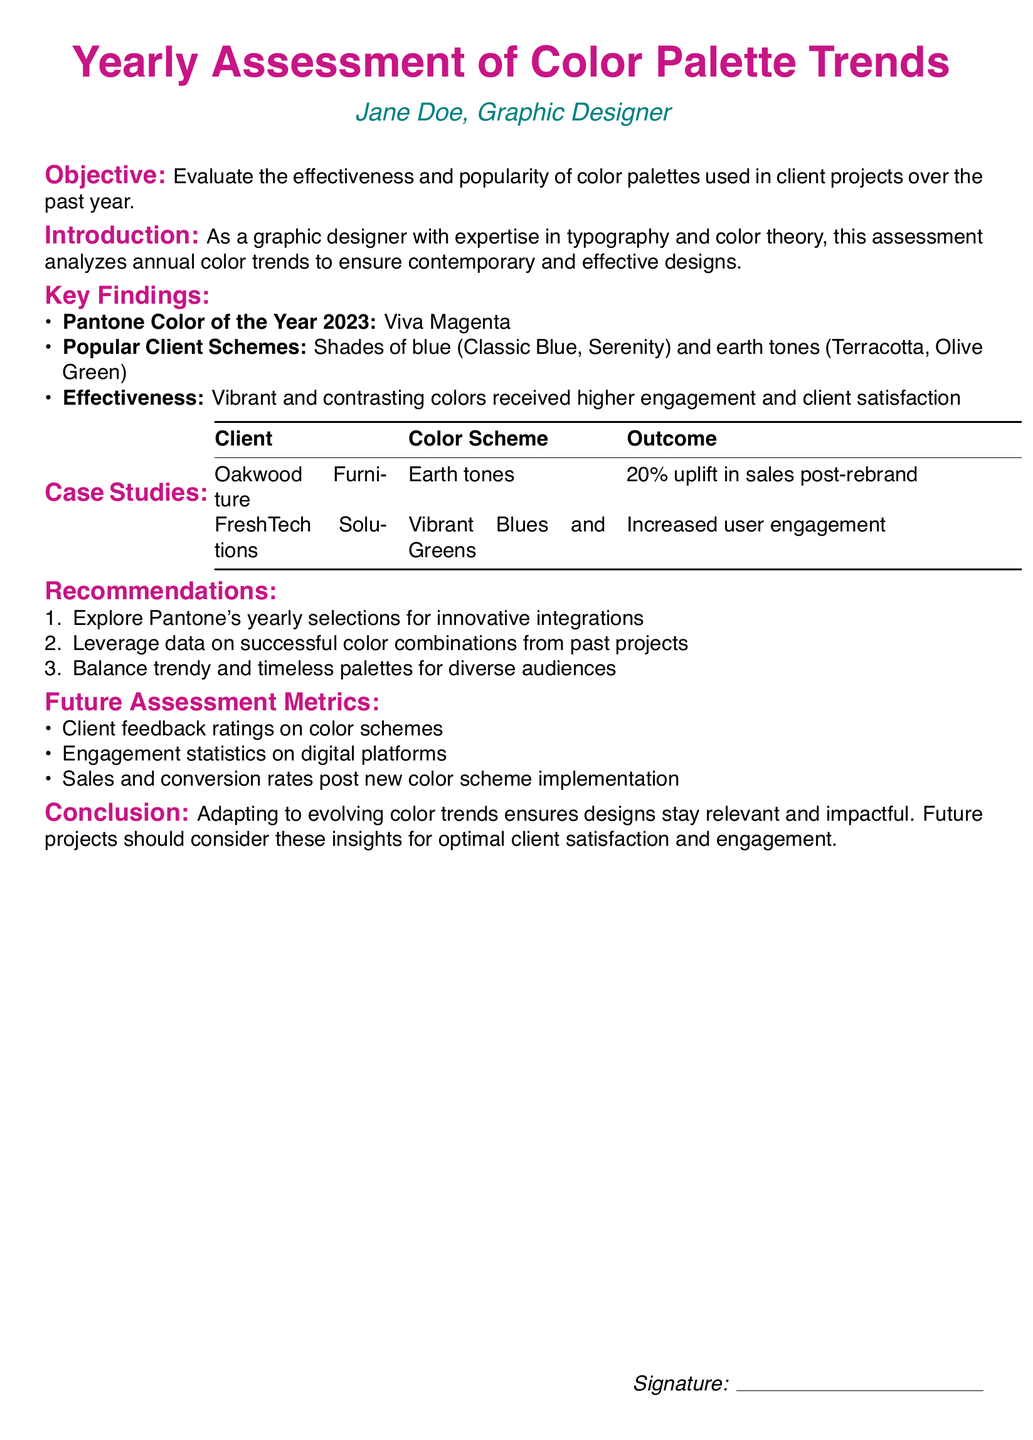What is the Pantone Color of the Year 2023? The document mentions that the Pantone Color of the Year 2023 is "Viva Magenta."
Answer: Viva Magenta Which client experienced a 20% uplift in sales? The document states that "Oakwood Furniture" had a 20% uplift in sales post-rebrand.
Answer: Oakwood Furniture What color schemes were noted as popular among clients? The assessment lists "Shades of blue" and "earth tones" as popular color schemes.
Answer: Shades of blue and earth tones What type of outcomes were achieved with vibrant colors? The document indicates that vibrant colors received "higher engagement and client satisfaction."
Answer: Higher engagement and client satisfaction What is one of the recommendations for future projects? The document suggests exploring "Pantone's yearly selections for innovative integrations" as a recommendation.
Answer: Explore Pantone's yearly selections Which organization is represented by Jane Doe? The document lists "Jane Doe" as the graphic designer.
Answer: Jane Doe What is included in the future assessment metrics? The document lists "Client feedback ratings on color schemes" as one of the metrics.
Answer: Client feedback ratings on color schemes How much sales uplift did Oakwood Furniture achieve? The document states a "20% uplift in sales" for Oakwood Furniture.
Answer: 20% uplift in sales What outcome was achieved by FreshTech Solutions? The assessment indicates that "Increased user engagement" was the outcome for FreshTech Solutions.
Answer: Increased user engagement 